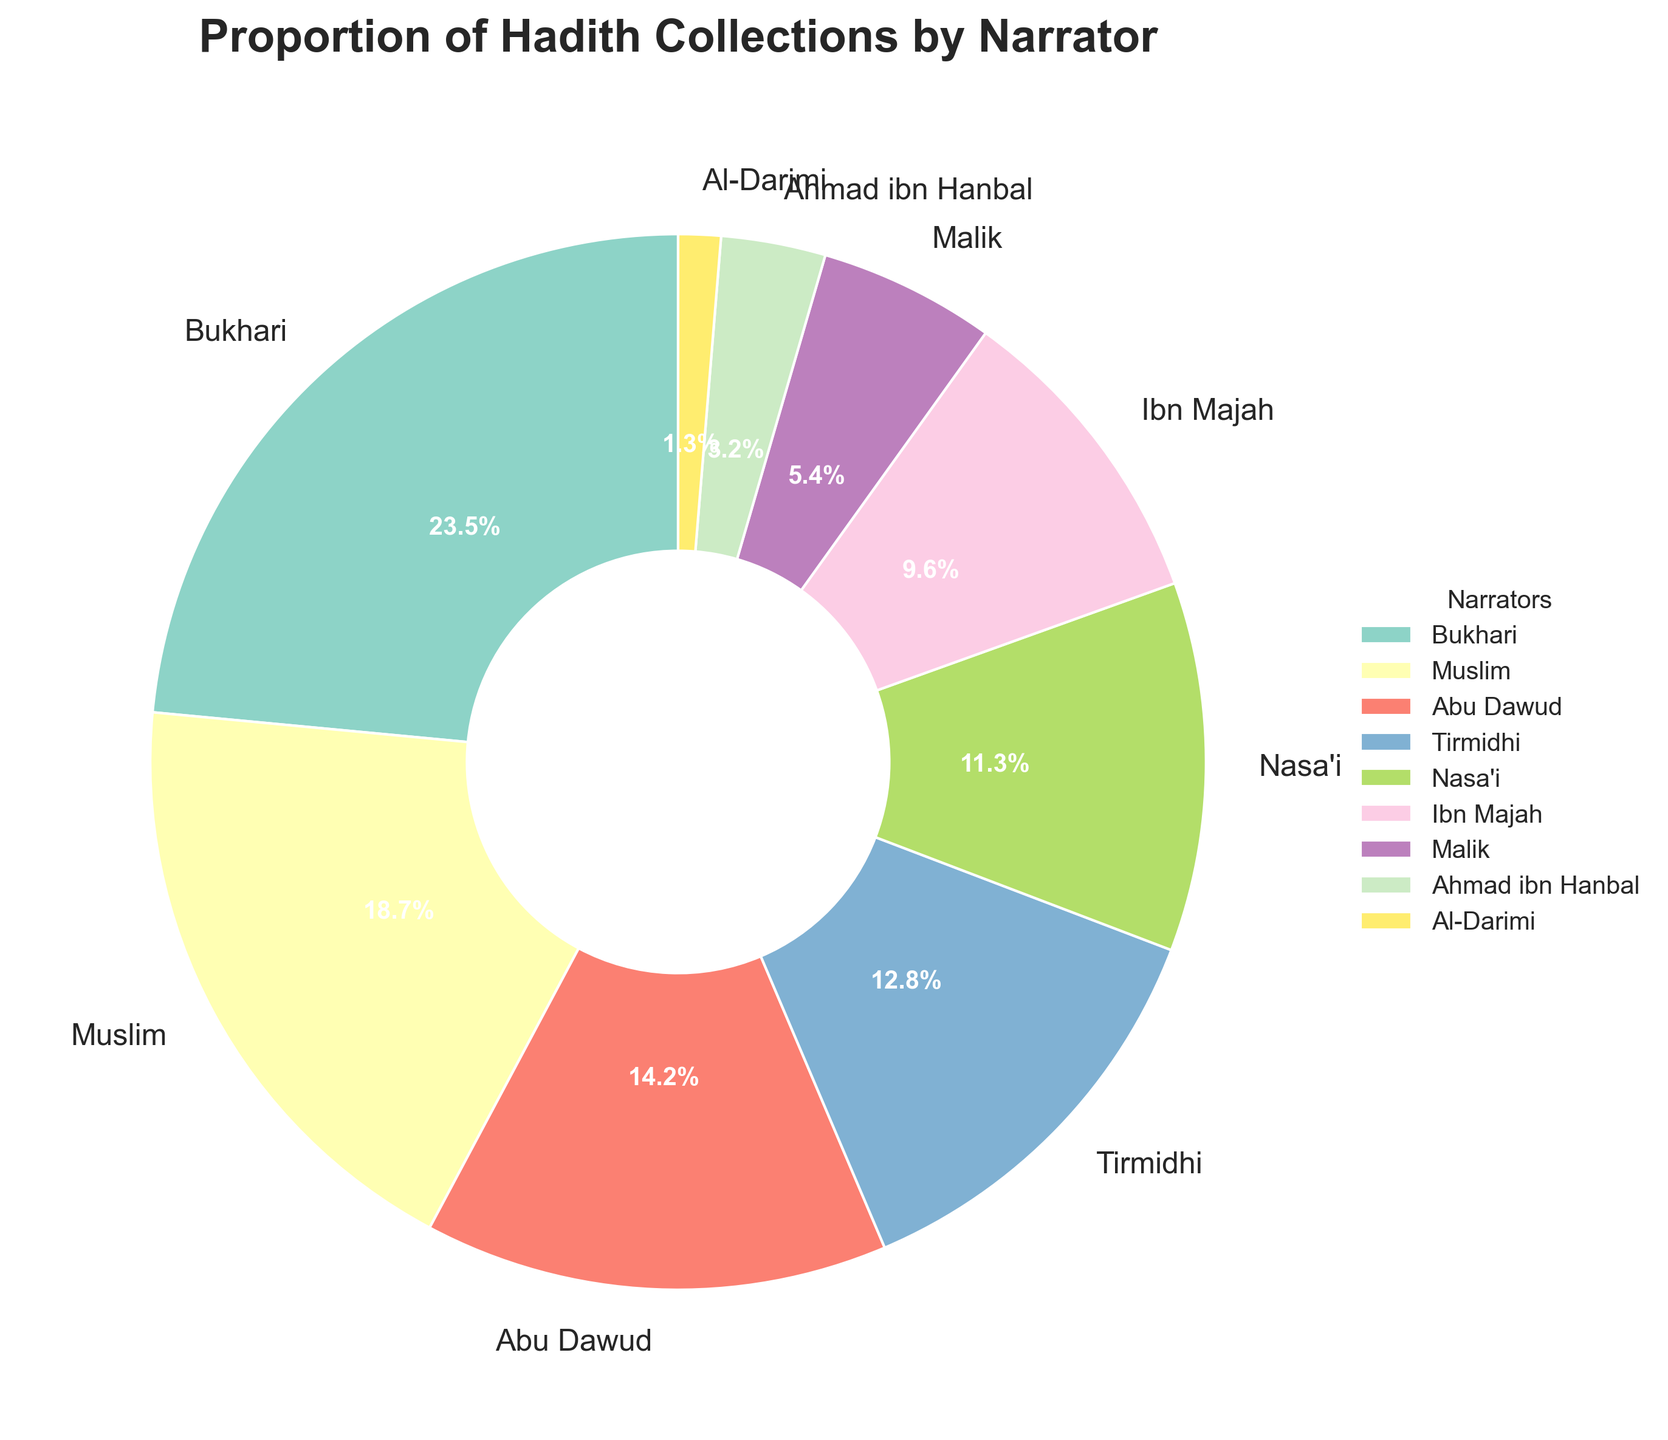Which narrator has the largest proportion of hadith collections? Looking at the pie chart, the wedge with the largest size is labeled "Bukhari" with 23.5%.
Answer: Bukhari Which narrators have a proportion greater than 10%? By observing the pie chart, the narrators with proportions greater than 10% are Bukhari (23.5%), Muslim (18.7%), Abu Dawud (14.2%), Tirmidhi (12.8%), and Nasa'i (11.3%).
Answer: Bukhari, Muslim, Abu Dawud, Tirmidhi, Nasa'i What is the combined proportion of the hadith collections attributed to Ibn Majah and Malik? Referring to the pie chart, Ibn Majah has a proportion of 9.6%, and Malik has 5.4%. Adding them together gives 9.6 + 5.4 = 15.0%.
Answer: 15.0% Which narrator has the smallest proportion, and what is it? The wedge with the smallest size is labeled "Al-Darimi" with 1.3%.
Answer: Al-Darimi, 1.3% How does the proportion of hadith collections attributed to Ahmad ibn Hanbal compare to Abu Dawud? Ahmad ibn Hanbal has a proportion of 3.2%, while Abu Dawud has 14.2%. So, Abu Dawud has a significantly larger proportion.
Answer: Ahmad ibn Hanbal has less, 3.2% vs 14.2% What percentage of hadith collections is attributed to narrators other than Bukhari? Bukhari’s proportion is 23.5%, so the remaining percentage is 100% - 23.5% = 76.5%.
Answer: 76.5% Among the listed narrators, who has a proportion closest to 10%, and what is the exact value? Observing the pie chart, Ibn Majah is the closest to 10% with a proportion of 9.6%.
Answer: Ibn Majah, 9.6% Is the combined proportion of Muslim and Abu Dawud greater than that of Bukhari alone? If yes, by how much? Muslim's proportion is 18.7%, and Abu Dawud's is 14.2%. Adding them gives 18.7 + 14.2 = 32.9%. Bukhari’s proportion is 23.5%. The difference is 32.9% - 23.5% = 9.4%.
Answer: Yes, by 9.4% If you sum the proportions of Tirmidhi, Nasa'i, and Ahmad ibn Hanbal, what do you get? Summing the proportions from the chart: Tirmidhi (12.8%) + Nasa'i (11.3%) + Ahmad ibn Hanbal (3.2%) = 12.8 + 11.3 + 3.2 = 27.3%.
Answer: 27.3% 